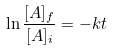<formula> <loc_0><loc_0><loc_500><loc_500>\ln \frac { [ A ] _ { f } } { [ A ] _ { i } } = - k t</formula> 